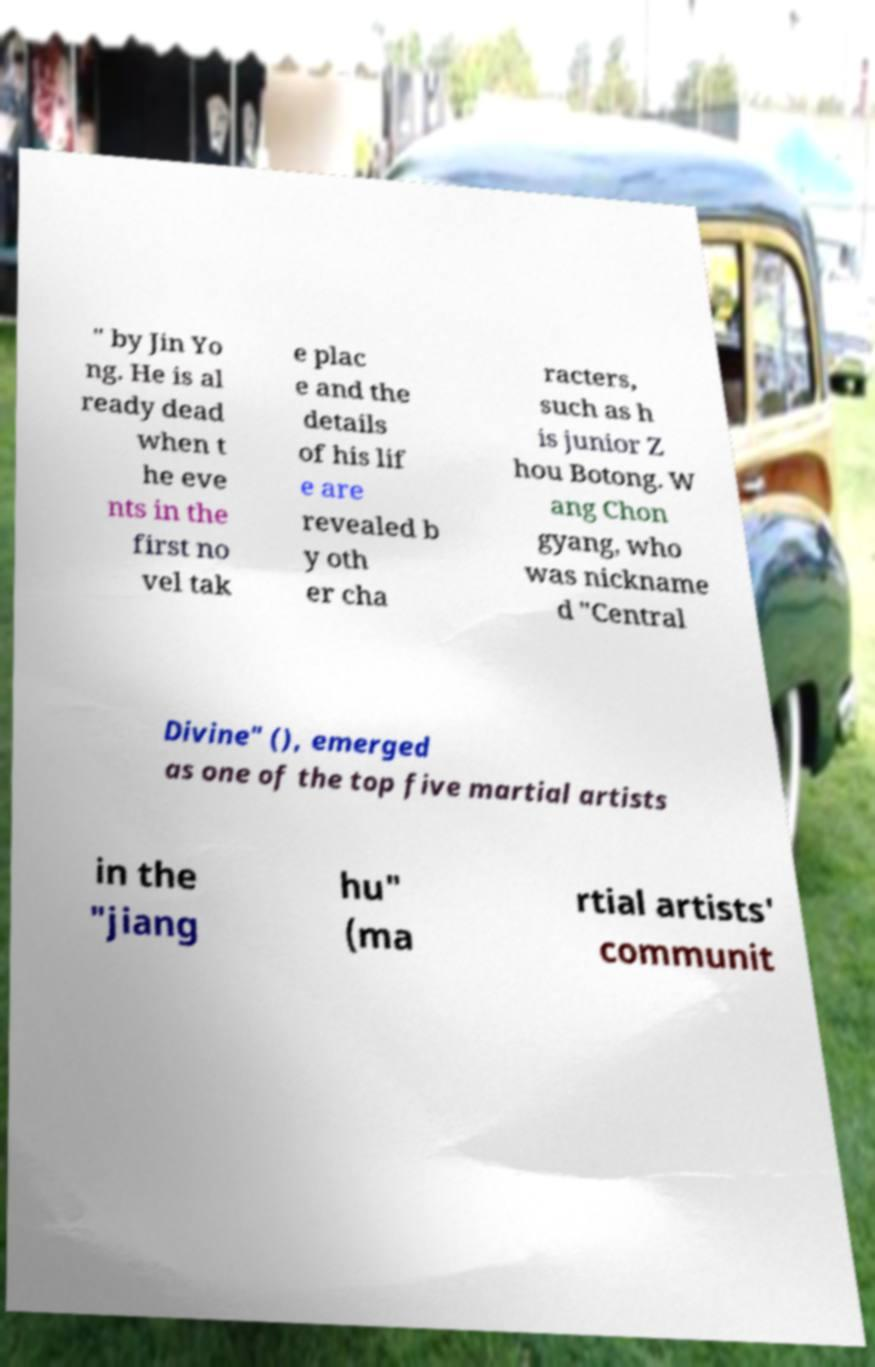Could you extract and type out the text from this image? " by Jin Yo ng. He is al ready dead when t he eve nts in the first no vel tak e plac e and the details of his lif e are revealed b y oth er cha racters, such as h is junior Z hou Botong. W ang Chon gyang, who was nickname d "Central Divine" (), emerged as one of the top five martial artists in the "jiang hu" (ma rtial artists' communit 